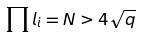Convert formula to latex. <formula><loc_0><loc_0><loc_500><loc_500>\prod l _ { i } = N > 4 \sqrt { q }</formula> 